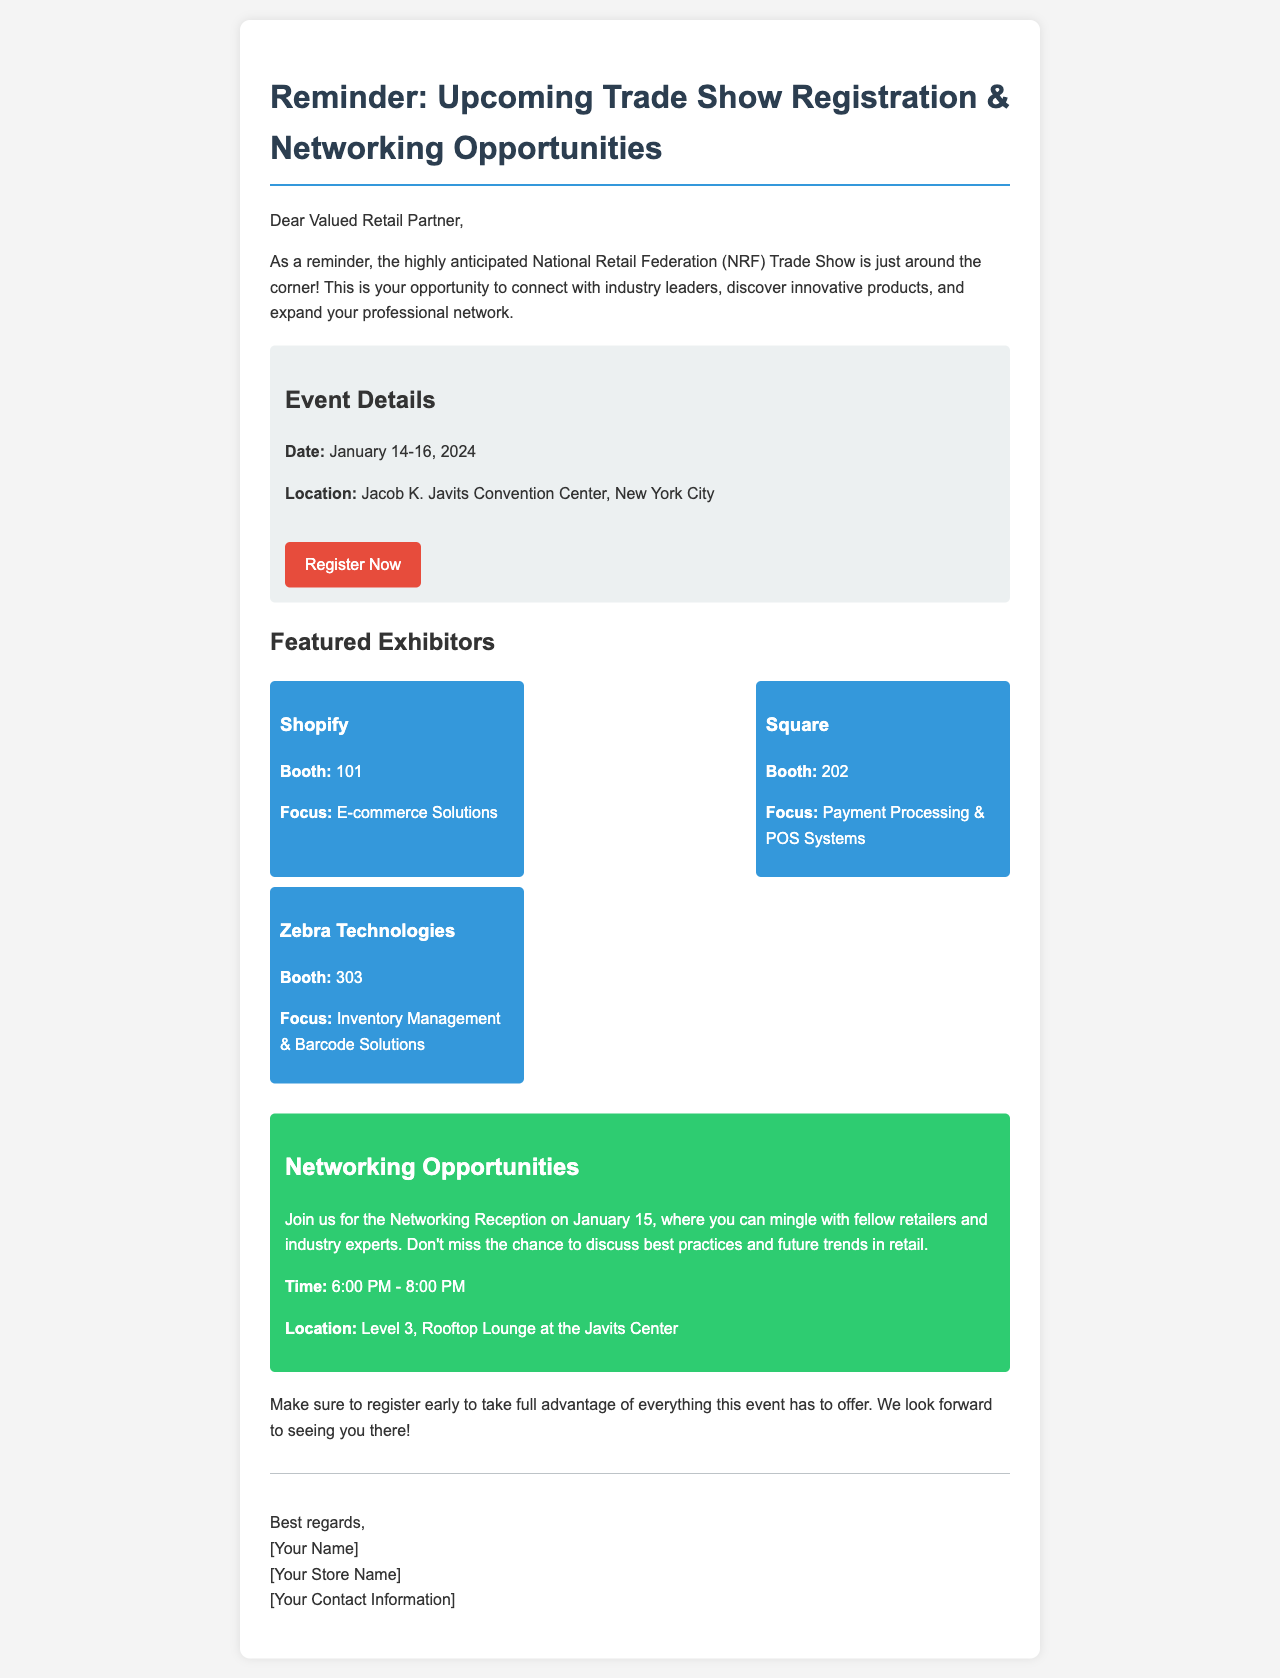what are the dates of the trade show? The trade show runs from January 14 to January 16, 2024, as stated in the event details.
Answer: January 14-16, 2024 where is the trade show being held? The location is specified as the Jacob K. Javits Convention Center, New York City.
Answer: Jacob K. Javits Convention Center, New York City who is an exhibitor focused on payment processing? The document lists Square as an exhibitor with a focus on Payment Processing & POS Systems.
Answer: Square what is the time of the networking reception? The networking reception is scheduled to occur from 6:00 PM to 8:00 PM.
Answer: 6:00 PM - 8:00 PM how many featured exhibitors are mentioned? Three exhibitors are detailed in the document, highlighted in the exhibitor list.
Answer: Three why is it important to register early? The document suggests registering early to take full advantage of the event opportunities.
Answer: To take full advantage of everything what should one not miss during the networking reception? The document emphasizes the chance to discuss best practices and future trends during this event.
Answer: Discuss best practices and future trends 